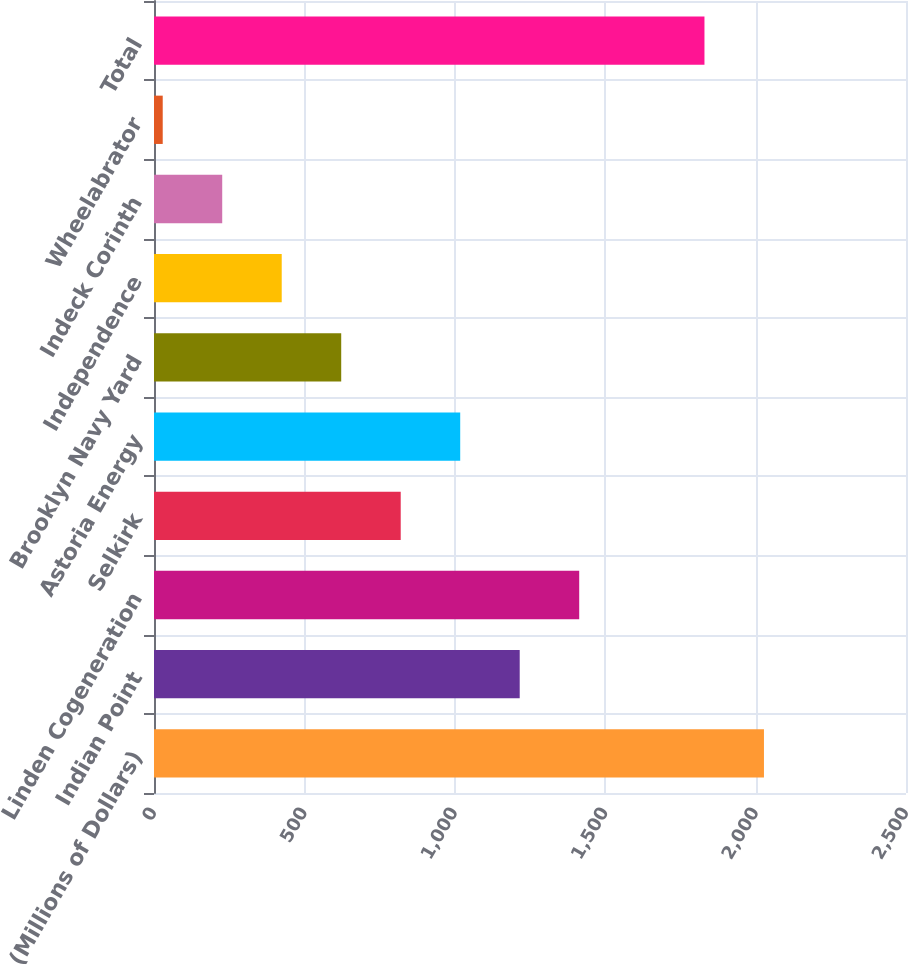Convert chart to OTSL. <chart><loc_0><loc_0><loc_500><loc_500><bar_chart><fcel>(Millions of Dollars)<fcel>Indian Point<fcel>Linden Cogeneration<fcel>Selkirk<fcel>Astoria Energy<fcel>Brooklyn Navy Yard<fcel>Independence<fcel>Indeck Corinth<fcel>Wheelabrator<fcel>Total<nl><fcel>2027.8<fcel>1215.8<fcel>1413.6<fcel>820.2<fcel>1018<fcel>622.4<fcel>424.6<fcel>226.8<fcel>29<fcel>1830<nl></chart> 